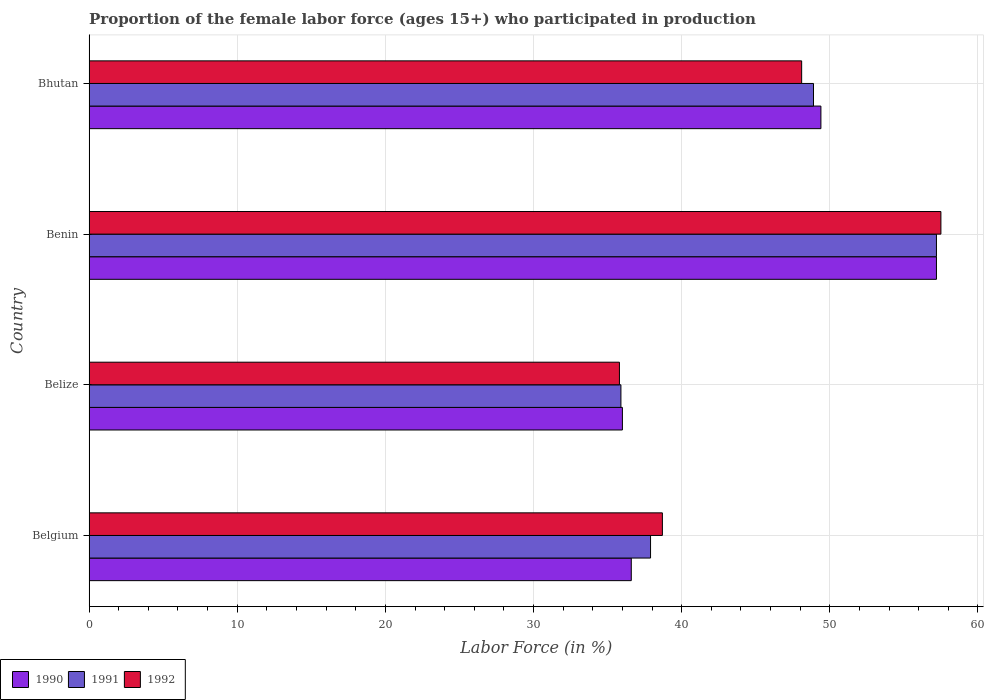How many different coloured bars are there?
Ensure brevity in your answer.  3. How many groups of bars are there?
Give a very brief answer. 4. Are the number of bars per tick equal to the number of legend labels?
Provide a succinct answer. Yes. Are the number of bars on each tick of the Y-axis equal?
Give a very brief answer. Yes. In how many cases, is the number of bars for a given country not equal to the number of legend labels?
Provide a succinct answer. 0. What is the proportion of the female labor force who participated in production in 1992 in Benin?
Keep it short and to the point. 57.5. Across all countries, what is the maximum proportion of the female labor force who participated in production in 1991?
Provide a succinct answer. 57.2. Across all countries, what is the minimum proportion of the female labor force who participated in production in 1992?
Your answer should be compact. 35.8. In which country was the proportion of the female labor force who participated in production in 1991 maximum?
Offer a terse response. Benin. In which country was the proportion of the female labor force who participated in production in 1990 minimum?
Your answer should be compact. Belize. What is the total proportion of the female labor force who participated in production in 1990 in the graph?
Offer a very short reply. 179.2. What is the difference between the proportion of the female labor force who participated in production in 1990 in Belgium and that in Belize?
Provide a succinct answer. 0.6. What is the difference between the proportion of the female labor force who participated in production in 1991 in Bhutan and the proportion of the female labor force who participated in production in 1992 in Belgium?
Ensure brevity in your answer.  10.2. What is the average proportion of the female labor force who participated in production in 1990 per country?
Keep it short and to the point. 44.8. What is the difference between the proportion of the female labor force who participated in production in 1992 and proportion of the female labor force who participated in production in 1991 in Bhutan?
Your answer should be very brief. -0.8. In how many countries, is the proportion of the female labor force who participated in production in 1992 greater than 8 %?
Your response must be concise. 4. What is the ratio of the proportion of the female labor force who participated in production in 1991 in Belgium to that in Bhutan?
Keep it short and to the point. 0.78. What is the difference between the highest and the second highest proportion of the female labor force who participated in production in 1990?
Your answer should be very brief. 7.8. What is the difference between the highest and the lowest proportion of the female labor force who participated in production in 1990?
Your answer should be compact. 21.2. In how many countries, is the proportion of the female labor force who participated in production in 1990 greater than the average proportion of the female labor force who participated in production in 1990 taken over all countries?
Your response must be concise. 2. What does the 1st bar from the bottom in Benin represents?
Ensure brevity in your answer.  1990. How many bars are there?
Provide a short and direct response. 12. How many countries are there in the graph?
Give a very brief answer. 4. What is the difference between two consecutive major ticks on the X-axis?
Provide a succinct answer. 10. Are the values on the major ticks of X-axis written in scientific E-notation?
Keep it short and to the point. No. Does the graph contain any zero values?
Ensure brevity in your answer.  No. What is the title of the graph?
Give a very brief answer. Proportion of the female labor force (ages 15+) who participated in production. What is the Labor Force (in %) in 1990 in Belgium?
Your answer should be compact. 36.6. What is the Labor Force (in %) in 1991 in Belgium?
Keep it short and to the point. 37.9. What is the Labor Force (in %) of 1992 in Belgium?
Provide a succinct answer. 38.7. What is the Labor Force (in %) of 1990 in Belize?
Offer a terse response. 36. What is the Labor Force (in %) of 1991 in Belize?
Give a very brief answer. 35.9. What is the Labor Force (in %) of 1992 in Belize?
Keep it short and to the point. 35.8. What is the Labor Force (in %) of 1990 in Benin?
Provide a succinct answer. 57.2. What is the Labor Force (in %) of 1991 in Benin?
Your response must be concise. 57.2. What is the Labor Force (in %) in 1992 in Benin?
Keep it short and to the point. 57.5. What is the Labor Force (in %) of 1990 in Bhutan?
Your answer should be very brief. 49.4. What is the Labor Force (in %) of 1991 in Bhutan?
Give a very brief answer. 48.9. What is the Labor Force (in %) of 1992 in Bhutan?
Ensure brevity in your answer.  48.1. Across all countries, what is the maximum Labor Force (in %) in 1990?
Your answer should be compact. 57.2. Across all countries, what is the maximum Labor Force (in %) of 1991?
Provide a short and direct response. 57.2. Across all countries, what is the maximum Labor Force (in %) of 1992?
Give a very brief answer. 57.5. Across all countries, what is the minimum Labor Force (in %) of 1991?
Your response must be concise. 35.9. Across all countries, what is the minimum Labor Force (in %) of 1992?
Provide a succinct answer. 35.8. What is the total Labor Force (in %) in 1990 in the graph?
Make the answer very short. 179.2. What is the total Labor Force (in %) of 1991 in the graph?
Provide a succinct answer. 179.9. What is the total Labor Force (in %) of 1992 in the graph?
Your response must be concise. 180.1. What is the difference between the Labor Force (in %) in 1991 in Belgium and that in Belize?
Your response must be concise. 2. What is the difference between the Labor Force (in %) in 1990 in Belgium and that in Benin?
Make the answer very short. -20.6. What is the difference between the Labor Force (in %) of 1991 in Belgium and that in Benin?
Provide a short and direct response. -19.3. What is the difference between the Labor Force (in %) of 1992 in Belgium and that in Benin?
Offer a terse response. -18.8. What is the difference between the Labor Force (in %) of 1990 in Belgium and that in Bhutan?
Your response must be concise. -12.8. What is the difference between the Labor Force (in %) in 1992 in Belgium and that in Bhutan?
Ensure brevity in your answer.  -9.4. What is the difference between the Labor Force (in %) in 1990 in Belize and that in Benin?
Provide a succinct answer. -21.2. What is the difference between the Labor Force (in %) in 1991 in Belize and that in Benin?
Give a very brief answer. -21.3. What is the difference between the Labor Force (in %) of 1992 in Belize and that in Benin?
Offer a very short reply. -21.7. What is the difference between the Labor Force (in %) of 1992 in Belize and that in Bhutan?
Your answer should be very brief. -12.3. What is the difference between the Labor Force (in %) in 1990 in Benin and that in Bhutan?
Ensure brevity in your answer.  7.8. What is the difference between the Labor Force (in %) in 1991 in Benin and that in Bhutan?
Keep it short and to the point. 8.3. What is the difference between the Labor Force (in %) of 1990 in Belgium and the Labor Force (in %) of 1992 in Belize?
Your answer should be compact. 0.8. What is the difference between the Labor Force (in %) in 1991 in Belgium and the Labor Force (in %) in 1992 in Belize?
Offer a terse response. 2.1. What is the difference between the Labor Force (in %) of 1990 in Belgium and the Labor Force (in %) of 1991 in Benin?
Give a very brief answer. -20.6. What is the difference between the Labor Force (in %) in 1990 in Belgium and the Labor Force (in %) in 1992 in Benin?
Offer a very short reply. -20.9. What is the difference between the Labor Force (in %) in 1991 in Belgium and the Labor Force (in %) in 1992 in Benin?
Offer a very short reply. -19.6. What is the difference between the Labor Force (in %) in 1990 in Belgium and the Labor Force (in %) in 1991 in Bhutan?
Your answer should be compact. -12.3. What is the difference between the Labor Force (in %) in 1990 in Belize and the Labor Force (in %) in 1991 in Benin?
Ensure brevity in your answer.  -21.2. What is the difference between the Labor Force (in %) in 1990 in Belize and the Labor Force (in %) in 1992 in Benin?
Keep it short and to the point. -21.5. What is the difference between the Labor Force (in %) in 1991 in Belize and the Labor Force (in %) in 1992 in Benin?
Offer a very short reply. -21.6. What is the difference between the Labor Force (in %) of 1990 in Belize and the Labor Force (in %) of 1991 in Bhutan?
Your response must be concise. -12.9. What is the difference between the Labor Force (in %) in 1991 in Belize and the Labor Force (in %) in 1992 in Bhutan?
Provide a short and direct response. -12.2. What is the difference between the Labor Force (in %) in 1990 in Benin and the Labor Force (in %) in 1991 in Bhutan?
Your answer should be compact. 8.3. What is the average Labor Force (in %) in 1990 per country?
Ensure brevity in your answer.  44.8. What is the average Labor Force (in %) of 1991 per country?
Make the answer very short. 44.98. What is the average Labor Force (in %) in 1992 per country?
Your answer should be very brief. 45.02. What is the difference between the Labor Force (in %) in 1990 and Labor Force (in %) in 1991 in Belgium?
Your answer should be very brief. -1.3. What is the difference between the Labor Force (in %) in 1990 and Labor Force (in %) in 1991 in Belize?
Give a very brief answer. 0.1. What is the difference between the Labor Force (in %) of 1990 and Labor Force (in %) of 1992 in Belize?
Provide a short and direct response. 0.2. What is the difference between the Labor Force (in %) of 1990 and Labor Force (in %) of 1991 in Benin?
Provide a succinct answer. 0. What is the difference between the Labor Force (in %) of 1991 and Labor Force (in %) of 1992 in Benin?
Keep it short and to the point. -0.3. What is the difference between the Labor Force (in %) in 1990 and Labor Force (in %) in 1991 in Bhutan?
Make the answer very short. 0.5. What is the difference between the Labor Force (in %) of 1990 and Labor Force (in %) of 1992 in Bhutan?
Provide a succinct answer. 1.3. What is the difference between the Labor Force (in %) in 1991 and Labor Force (in %) in 1992 in Bhutan?
Give a very brief answer. 0.8. What is the ratio of the Labor Force (in %) of 1990 in Belgium to that in Belize?
Give a very brief answer. 1.02. What is the ratio of the Labor Force (in %) of 1991 in Belgium to that in Belize?
Ensure brevity in your answer.  1.06. What is the ratio of the Labor Force (in %) in 1992 in Belgium to that in Belize?
Keep it short and to the point. 1.08. What is the ratio of the Labor Force (in %) of 1990 in Belgium to that in Benin?
Your answer should be compact. 0.64. What is the ratio of the Labor Force (in %) of 1991 in Belgium to that in Benin?
Ensure brevity in your answer.  0.66. What is the ratio of the Labor Force (in %) in 1992 in Belgium to that in Benin?
Ensure brevity in your answer.  0.67. What is the ratio of the Labor Force (in %) in 1990 in Belgium to that in Bhutan?
Your answer should be very brief. 0.74. What is the ratio of the Labor Force (in %) in 1991 in Belgium to that in Bhutan?
Provide a succinct answer. 0.78. What is the ratio of the Labor Force (in %) of 1992 in Belgium to that in Bhutan?
Keep it short and to the point. 0.8. What is the ratio of the Labor Force (in %) of 1990 in Belize to that in Benin?
Ensure brevity in your answer.  0.63. What is the ratio of the Labor Force (in %) in 1991 in Belize to that in Benin?
Your answer should be very brief. 0.63. What is the ratio of the Labor Force (in %) in 1992 in Belize to that in Benin?
Your answer should be very brief. 0.62. What is the ratio of the Labor Force (in %) in 1990 in Belize to that in Bhutan?
Your answer should be very brief. 0.73. What is the ratio of the Labor Force (in %) in 1991 in Belize to that in Bhutan?
Make the answer very short. 0.73. What is the ratio of the Labor Force (in %) of 1992 in Belize to that in Bhutan?
Keep it short and to the point. 0.74. What is the ratio of the Labor Force (in %) in 1990 in Benin to that in Bhutan?
Your answer should be very brief. 1.16. What is the ratio of the Labor Force (in %) of 1991 in Benin to that in Bhutan?
Provide a short and direct response. 1.17. What is the ratio of the Labor Force (in %) of 1992 in Benin to that in Bhutan?
Your answer should be very brief. 1.2. What is the difference between the highest and the second highest Labor Force (in %) of 1990?
Your answer should be compact. 7.8. What is the difference between the highest and the second highest Labor Force (in %) in 1991?
Offer a terse response. 8.3. What is the difference between the highest and the lowest Labor Force (in %) in 1990?
Ensure brevity in your answer.  21.2. What is the difference between the highest and the lowest Labor Force (in %) of 1991?
Your answer should be compact. 21.3. What is the difference between the highest and the lowest Labor Force (in %) of 1992?
Offer a terse response. 21.7. 